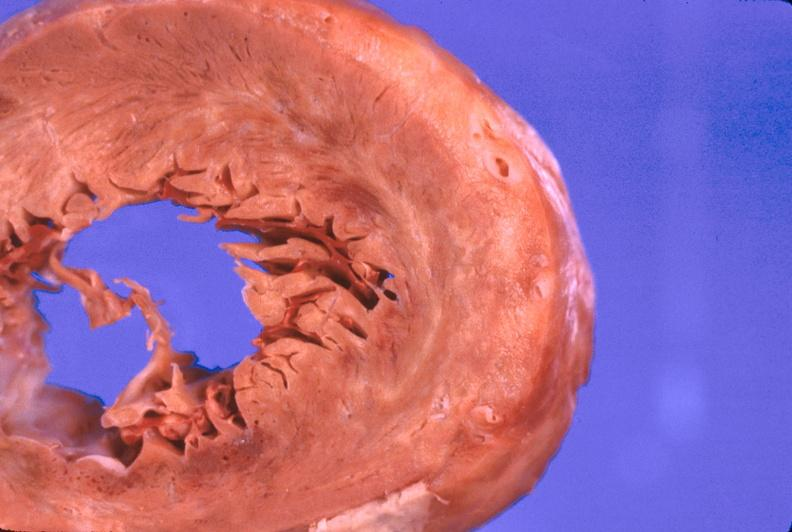does this image show heart, myocardial infarction free wall, 6 days old, in a patient with diabetes mellitus and hypertension?
Answer the question using a single word or phrase. Yes 